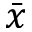<formula> <loc_0><loc_0><loc_500><loc_500>\bar { x }</formula> 